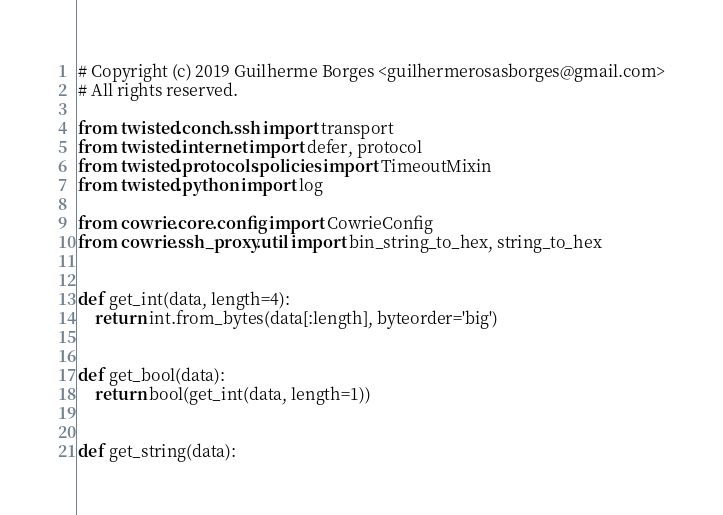<code> <loc_0><loc_0><loc_500><loc_500><_Python_># Copyright (c) 2019 Guilherme Borges <guilhermerosasborges@gmail.com>
# All rights reserved.

from twisted.conch.ssh import transport
from twisted.internet import defer, protocol
from twisted.protocols.policies import TimeoutMixin
from twisted.python import log

from cowrie.core.config import CowrieConfig
from cowrie.ssh_proxy.util import bin_string_to_hex, string_to_hex


def get_int(data, length=4):
    return int.from_bytes(data[:length], byteorder='big')


def get_bool(data):
    return bool(get_int(data, length=1))


def get_string(data):</code> 